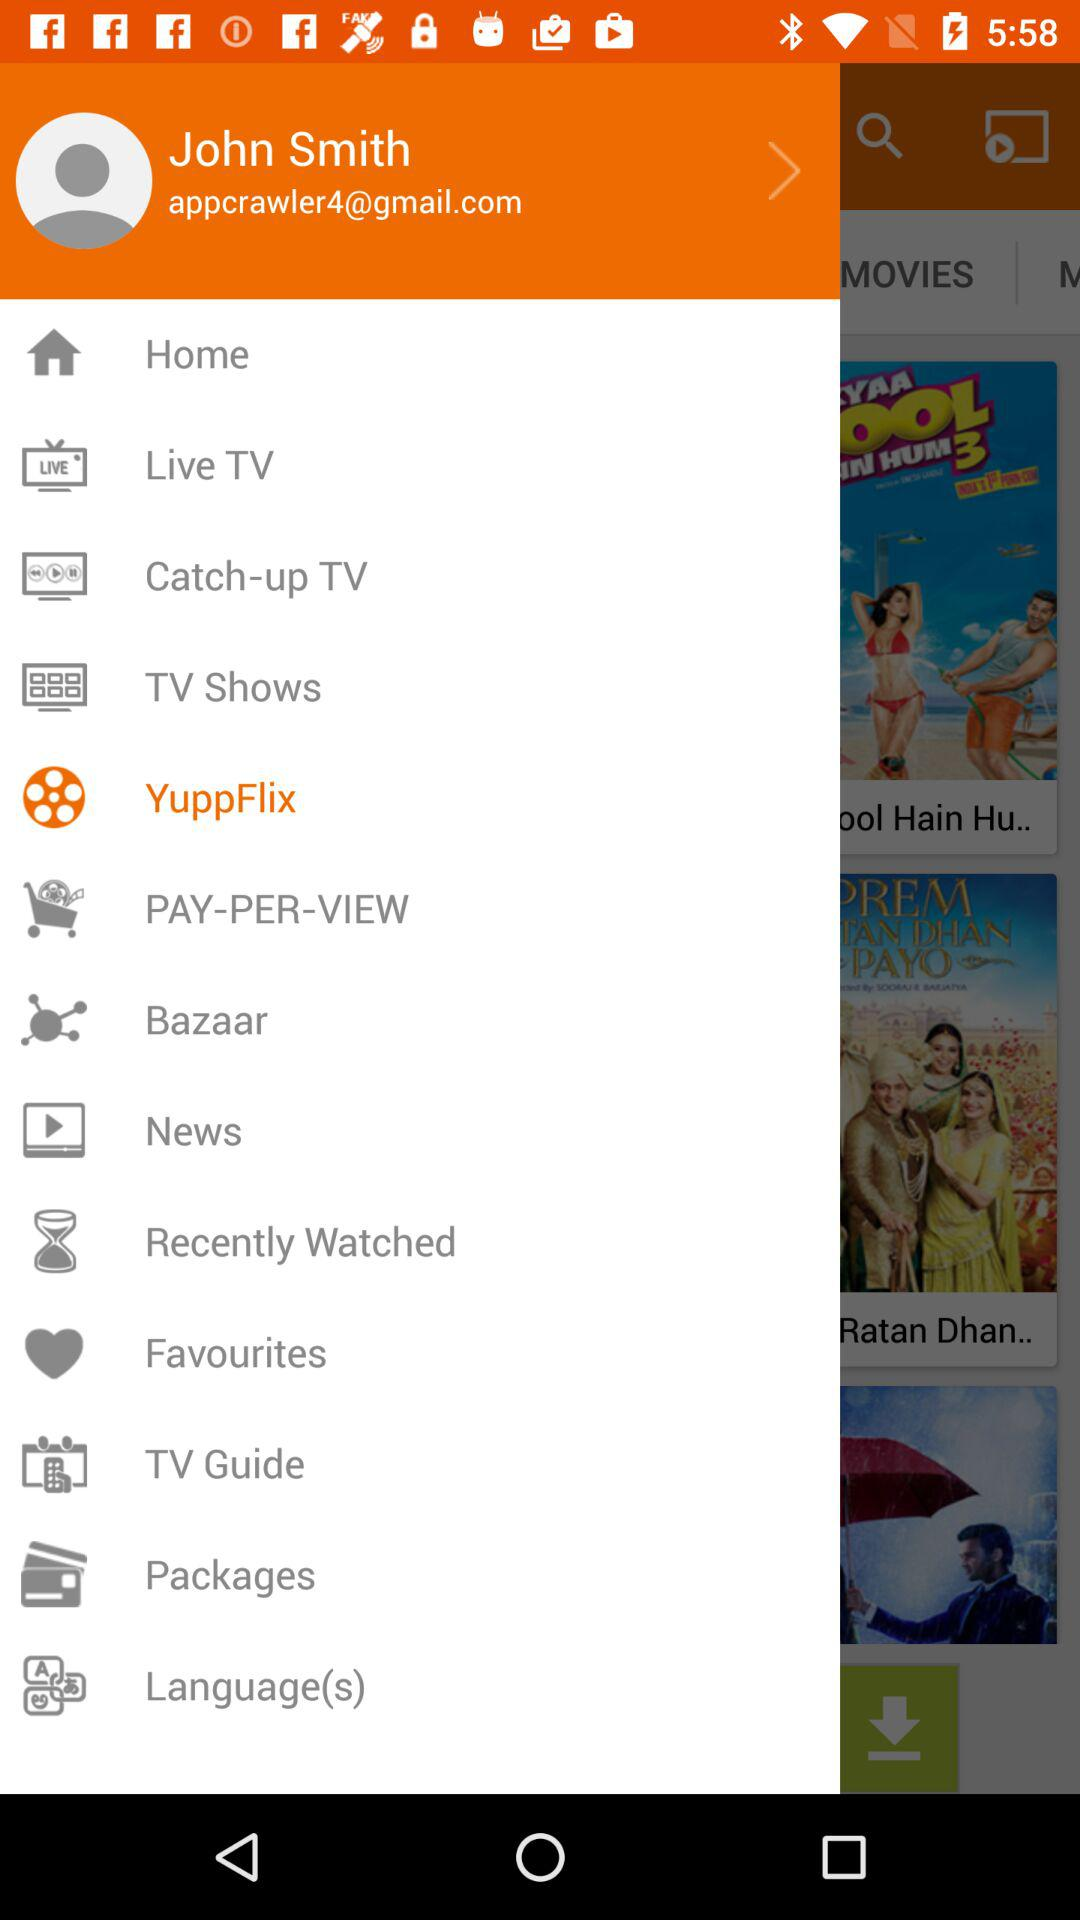Which item is selected in the menu? The selected item is "YuppFlix". 